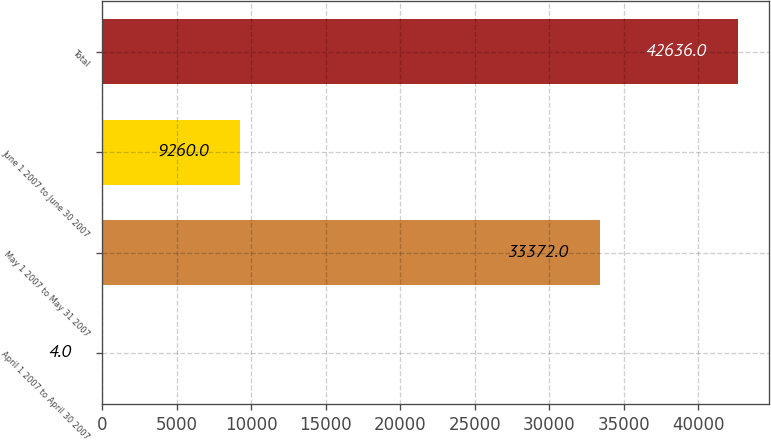<chart> <loc_0><loc_0><loc_500><loc_500><bar_chart><fcel>April 1 2007 to April 30 2007<fcel>May 1 2007 to May 31 2007<fcel>June 1 2007 to June 30 2007<fcel>Total<nl><fcel>4<fcel>33372<fcel>9260<fcel>42636<nl></chart> 